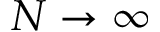<formula> <loc_0><loc_0><loc_500><loc_500>N \to \infty</formula> 